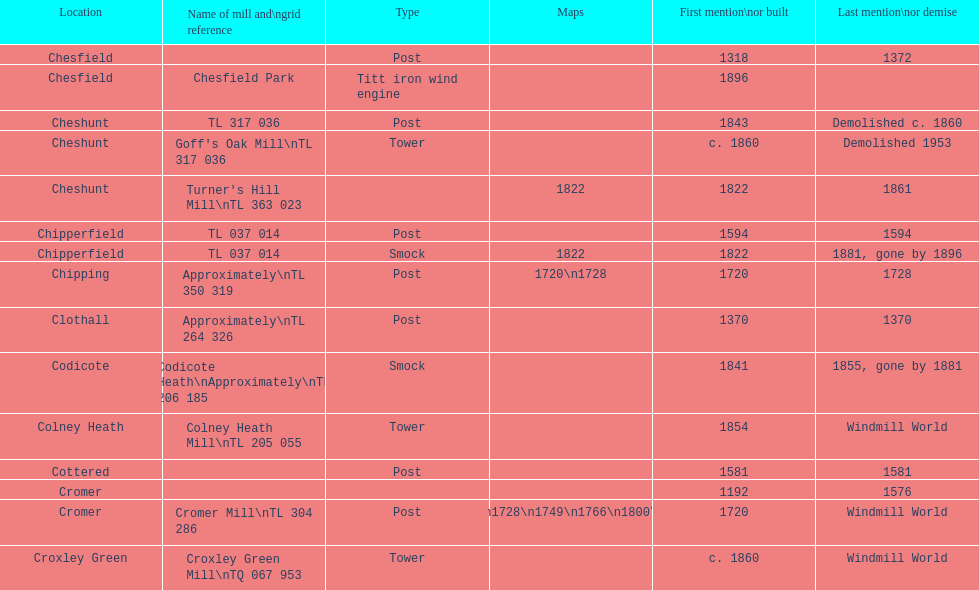What is the designation of the unique "c" mill found in colney health? Colney Heath Mill. 